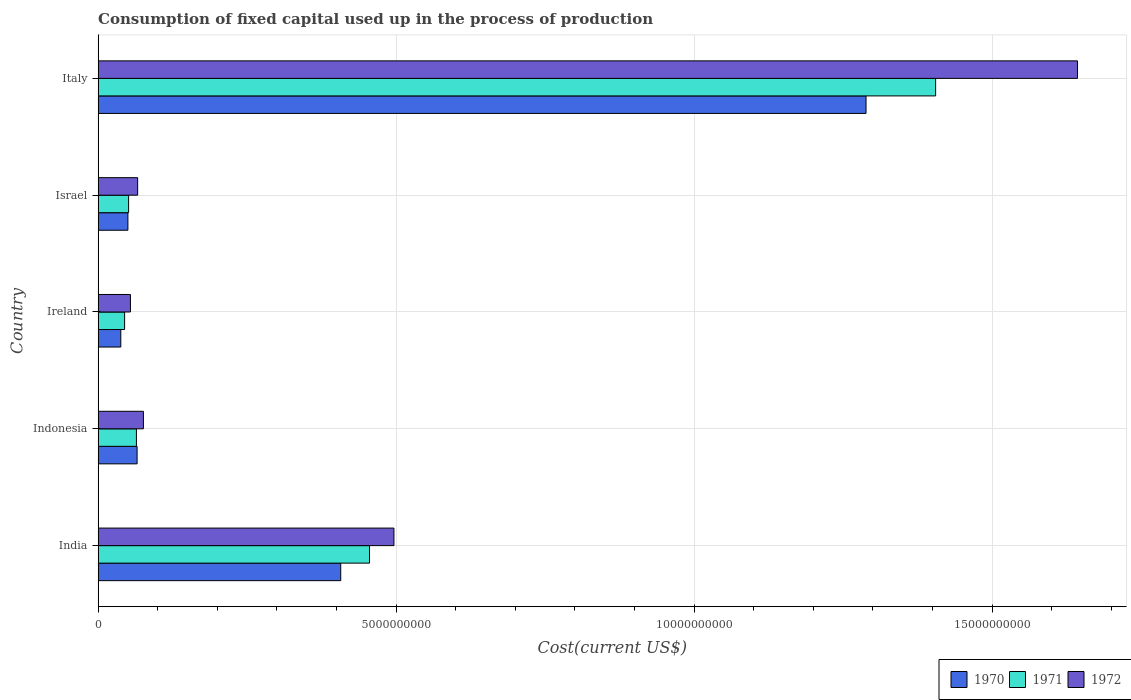How many different coloured bars are there?
Offer a very short reply. 3. How many groups of bars are there?
Provide a short and direct response. 5. Are the number of bars on each tick of the Y-axis equal?
Offer a very short reply. Yes. How many bars are there on the 5th tick from the top?
Offer a very short reply. 3. What is the amount consumed in the process of production in 1972 in Italy?
Your answer should be compact. 1.64e+1. Across all countries, what is the maximum amount consumed in the process of production in 1971?
Ensure brevity in your answer.  1.41e+1. Across all countries, what is the minimum amount consumed in the process of production in 1970?
Your response must be concise. 3.81e+08. In which country was the amount consumed in the process of production in 1970 maximum?
Make the answer very short. Italy. In which country was the amount consumed in the process of production in 1971 minimum?
Give a very brief answer. Ireland. What is the total amount consumed in the process of production in 1972 in the graph?
Give a very brief answer. 2.34e+1. What is the difference between the amount consumed in the process of production in 1972 in Israel and that in Italy?
Your response must be concise. -1.58e+1. What is the difference between the amount consumed in the process of production in 1970 in Ireland and the amount consumed in the process of production in 1972 in Indonesia?
Offer a terse response. -3.79e+08. What is the average amount consumed in the process of production in 1972 per country?
Offer a very short reply. 4.67e+09. What is the difference between the amount consumed in the process of production in 1970 and amount consumed in the process of production in 1971 in Italy?
Make the answer very short. -1.17e+09. What is the ratio of the amount consumed in the process of production in 1972 in Ireland to that in Italy?
Keep it short and to the point. 0.03. What is the difference between the highest and the second highest amount consumed in the process of production in 1972?
Your answer should be very brief. 1.15e+1. What is the difference between the highest and the lowest amount consumed in the process of production in 1971?
Provide a succinct answer. 1.36e+1. In how many countries, is the amount consumed in the process of production in 1970 greater than the average amount consumed in the process of production in 1970 taken over all countries?
Your answer should be compact. 2. What does the 1st bar from the top in Indonesia represents?
Provide a succinct answer. 1972. What does the 1st bar from the bottom in Indonesia represents?
Give a very brief answer. 1970. Is it the case that in every country, the sum of the amount consumed in the process of production in 1970 and amount consumed in the process of production in 1971 is greater than the amount consumed in the process of production in 1972?
Offer a terse response. Yes. How many countries are there in the graph?
Offer a terse response. 5. Where does the legend appear in the graph?
Make the answer very short. Bottom right. What is the title of the graph?
Your answer should be very brief. Consumption of fixed capital used up in the process of production. What is the label or title of the X-axis?
Offer a very short reply. Cost(current US$). What is the Cost(current US$) in 1970 in India?
Offer a very short reply. 4.07e+09. What is the Cost(current US$) of 1971 in India?
Offer a terse response. 4.55e+09. What is the Cost(current US$) of 1972 in India?
Provide a short and direct response. 4.96e+09. What is the Cost(current US$) of 1970 in Indonesia?
Ensure brevity in your answer.  6.54e+08. What is the Cost(current US$) in 1971 in Indonesia?
Provide a short and direct response. 6.43e+08. What is the Cost(current US$) of 1972 in Indonesia?
Your response must be concise. 7.60e+08. What is the Cost(current US$) of 1970 in Ireland?
Make the answer very short. 3.81e+08. What is the Cost(current US$) in 1971 in Ireland?
Give a very brief answer. 4.45e+08. What is the Cost(current US$) in 1972 in Ireland?
Offer a very short reply. 5.42e+08. What is the Cost(current US$) in 1970 in Israel?
Keep it short and to the point. 5.00e+08. What is the Cost(current US$) of 1971 in Israel?
Offer a very short reply. 5.12e+08. What is the Cost(current US$) of 1972 in Israel?
Ensure brevity in your answer.  6.63e+08. What is the Cost(current US$) of 1970 in Italy?
Offer a terse response. 1.29e+1. What is the Cost(current US$) of 1971 in Italy?
Your answer should be compact. 1.41e+1. What is the Cost(current US$) in 1972 in Italy?
Give a very brief answer. 1.64e+1. Across all countries, what is the maximum Cost(current US$) of 1970?
Your answer should be very brief. 1.29e+1. Across all countries, what is the maximum Cost(current US$) of 1971?
Your answer should be compact. 1.41e+1. Across all countries, what is the maximum Cost(current US$) in 1972?
Keep it short and to the point. 1.64e+1. Across all countries, what is the minimum Cost(current US$) in 1970?
Give a very brief answer. 3.81e+08. Across all countries, what is the minimum Cost(current US$) of 1971?
Offer a terse response. 4.45e+08. Across all countries, what is the minimum Cost(current US$) in 1972?
Offer a very short reply. 5.42e+08. What is the total Cost(current US$) in 1970 in the graph?
Offer a terse response. 1.85e+1. What is the total Cost(current US$) of 1971 in the graph?
Your answer should be compact. 2.02e+1. What is the total Cost(current US$) of 1972 in the graph?
Offer a terse response. 2.34e+1. What is the difference between the Cost(current US$) in 1970 in India and that in Indonesia?
Provide a succinct answer. 3.42e+09. What is the difference between the Cost(current US$) in 1971 in India and that in Indonesia?
Offer a terse response. 3.91e+09. What is the difference between the Cost(current US$) of 1972 in India and that in Indonesia?
Make the answer very short. 4.20e+09. What is the difference between the Cost(current US$) in 1970 in India and that in Ireland?
Provide a succinct answer. 3.69e+09. What is the difference between the Cost(current US$) in 1971 in India and that in Ireland?
Make the answer very short. 4.11e+09. What is the difference between the Cost(current US$) in 1972 in India and that in Ireland?
Ensure brevity in your answer.  4.42e+09. What is the difference between the Cost(current US$) of 1970 in India and that in Israel?
Your answer should be compact. 3.57e+09. What is the difference between the Cost(current US$) of 1971 in India and that in Israel?
Provide a short and direct response. 4.04e+09. What is the difference between the Cost(current US$) of 1972 in India and that in Israel?
Keep it short and to the point. 4.30e+09. What is the difference between the Cost(current US$) of 1970 in India and that in Italy?
Your answer should be very brief. -8.81e+09. What is the difference between the Cost(current US$) of 1971 in India and that in Italy?
Keep it short and to the point. -9.50e+09. What is the difference between the Cost(current US$) in 1972 in India and that in Italy?
Your response must be concise. -1.15e+1. What is the difference between the Cost(current US$) in 1970 in Indonesia and that in Ireland?
Make the answer very short. 2.73e+08. What is the difference between the Cost(current US$) in 1971 in Indonesia and that in Ireland?
Provide a short and direct response. 1.98e+08. What is the difference between the Cost(current US$) of 1972 in Indonesia and that in Ireland?
Your answer should be very brief. 2.18e+08. What is the difference between the Cost(current US$) of 1970 in Indonesia and that in Israel?
Give a very brief answer. 1.54e+08. What is the difference between the Cost(current US$) in 1971 in Indonesia and that in Israel?
Provide a short and direct response. 1.31e+08. What is the difference between the Cost(current US$) of 1972 in Indonesia and that in Israel?
Your answer should be compact. 9.66e+07. What is the difference between the Cost(current US$) in 1970 in Indonesia and that in Italy?
Provide a short and direct response. -1.22e+1. What is the difference between the Cost(current US$) in 1971 in Indonesia and that in Italy?
Make the answer very short. -1.34e+1. What is the difference between the Cost(current US$) in 1972 in Indonesia and that in Italy?
Provide a short and direct response. -1.57e+1. What is the difference between the Cost(current US$) in 1970 in Ireland and that in Israel?
Ensure brevity in your answer.  -1.19e+08. What is the difference between the Cost(current US$) in 1971 in Ireland and that in Israel?
Offer a very short reply. -6.70e+07. What is the difference between the Cost(current US$) in 1972 in Ireland and that in Israel?
Your response must be concise. -1.21e+08. What is the difference between the Cost(current US$) in 1970 in Ireland and that in Italy?
Make the answer very short. -1.25e+1. What is the difference between the Cost(current US$) of 1971 in Ireland and that in Italy?
Provide a short and direct response. -1.36e+1. What is the difference between the Cost(current US$) in 1972 in Ireland and that in Italy?
Keep it short and to the point. -1.59e+1. What is the difference between the Cost(current US$) in 1970 in Israel and that in Italy?
Keep it short and to the point. -1.24e+1. What is the difference between the Cost(current US$) of 1971 in Israel and that in Italy?
Give a very brief answer. -1.35e+1. What is the difference between the Cost(current US$) of 1972 in Israel and that in Italy?
Your answer should be very brief. -1.58e+1. What is the difference between the Cost(current US$) in 1970 in India and the Cost(current US$) in 1971 in Indonesia?
Give a very brief answer. 3.43e+09. What is the difference between the Cost(current US$) of 1970 in India and the Cost(current US$) of 1972 in Indonesia?
Your answer should be very brief. 3.31e+09. What is the difference between the Cost(current US$) of 1971 in India and the Cost(current US$) of 1972 in Indonesia?
Give a very brief answer. 3.79e+09. What is the difference between the Cost(current US$) of 1970 in India and the Cost(current US$) of 1971 in Ireland?
Provide a succinct answer. 3.63e+09. What is the difference between the Cost(current US$) in 1970 in India and the Cost(current US$) in 1972 in Ireland?
Offer a terse response. 3.53e+09. What is the difference between the Cost(current US$) of 1971 in India and the Cost(current US$) of 1972 in Ireland?
Give a very brief answer. 4.01e+09. What is the difference between the Cost(current US$) in 1970 in India and the Cost(current US$) in 1971 in Israel?
Keep it short and to the point. 3.56e+09. What is the difference between the Cost(current US$) of 1970 in India and the Cost(current US$) of 1972 in Israel?
Give a very brief answer. 3.41e+09. What is the difference between the Cost(current US$) in 1971 in India and the Cost(current US$) in 1972 in Israel?
Keep it short and to the point. 3.89e+09. What is the difference between the Cost(current US$) in 1970 in India and the Cost(current US$) in 1971 in Italy?
Your response must be concise. -9.98e+09. What is the difference between the Cost(current US$) in 1970 in India and the Cost(current US$) in 1972 in Italy?
Keep it short and to the point. -1.24e+1. What is the difference between the Cost(current US$) of 1971 in India and the Cost(current US$) of 1972 in Italy?
Provide a short and direct response. -1.19e+1. What is the difference between the Cost(current US$) of 1970 in Indonesia and the Cost(current US$) of 1971 in Ireland?
Offer a terse response. 2.09e+08. What is the difference between the Cost(current US$) of 1970 in Indonesia and the Cost(current US$) of 1972 in Ireland?
Provide a short and direct response. 1.12e+08. What is the difference between the Cost(current US$) in 1971 in Indonesia and the Cost(current US$) in 1972 in Ireland?
Provide a succinct answer. 1.01e+08. What is the difference between the Cost(current US$) in 1970 in Indonesia and the Cost(current US$) in 1971 in Israel?
Provide a short and direct response. 1.42e+08. What is the difference between the Cost(current US$) of 1970 in Indonesia and the Cost(current US$) of 1972 in Israel?
Ensure brevity in your answer.  -9.33e+06. What is the difference between the Cost(current US$) of 1971 in Indonesia and the Cost(current US$) of 1972 in Israel?
Offer a very short reply. -2.06e+07. What is the difference between the Cost(current US$) of 1970 in Indonesia and the Cost(current US$) of 1971 in Italy?
Your response must be concise. -1.34e+1. What is the difference between the Cost(current US$) of 1970 in Indonesia and the Cost(current US$) of 1972 in Italy?
Give a very brief answer. -1.58e+1. What is the difference between the Cost(current US$) in 1971 in Indonesia and the Cost(current US$) in 1972 in Italy?
Your answer should be compact. -1.58e+1. What is the difference between the Cost(current US$) of 1970 in Ireland and the Cost(current US$) of 1971 in Israel?
Your answer should be very brief. -1.31e+08. What is the difference between the Cost(current US$) of 1970 in Ireland and the Cost(current US$) of 1972 in Israel?
Your answer should be very brief. -2.83e+08. What is the difference between the Cost(current US$) in 1971 in Ireland and the Cost(current US$) in 1972 in Israel?
Give a very brief answer. -2.19e+08. What is the difference between the Cost(current US$) in 1970 in Ireland and the Cost(current US$) in 1971 in Italy?
Your answer should be compact. -1.37e+1. What is the difference between the Cost(current US$) of 1970 in Ireland and the Cost(current US$) of 1972 in Italy?
Ensure brevity in your answer.  -1.61e+1. What is the difference between the Cost(current US$) of 1971 in Ireland and the Cost(current US$) of 1972 in Italy?
Your answer should be compact. -1.60e+1. What is the difference between the Cost(current US$) in 1970 in Israel and the Cost(current US$) in 1971 in Italy?
Your answer should be very brief. -1.36e+1. What is the difference between the Cost(current US$) in 1970 in Israel and the Cost(current US$) in 1972 in Italy?
Your answer should be very brief. -1.59e+1. What is the difference between the Cost(current US$) of 1971 in Israel and the Cost(current US$) of 1972 in Italy?
Offer a terse response. -1.59e+1. What is the average Cost(current US$) of 1970 per country?
Your response must be concise. 3.70e+09. What is the average Cost(current US$) in 1971 per country?
Your response must be concise. 4.04e+09. What is the average Cost(current US$) in 1972 per country?
Make the answer very short. 4.67e+09. What is the difference between the Cost(current US$) in 1970 and Cost(current US$) in 1971 in India?
Your answer should be compact. -4.83e+08. What is the difference between the Cost(current US$) in 1970 and Cost(current US$) in 1972 in India?
Your answer should be compact. -8.93e+08. What is the difference between the Cost(current US$) in 1971 and Cost(current US$) in 1972 in India?
Your response must be concise. -4.09e+08. What is the difference between the Cost(current US$) of 1970 and Cost(current US$) of 1971 in Indonesia?
Provide a short and direct response. 1.13e+07. What is the difference between the Cost(current US$) of 1970 and Cost(current US$) of 1972 in Indonesia?
Your answer should be compact. -1.06e+08. What is the difference between the Cost(current US$) of 1971 and Cost(current US$) of 1972 in Indonesia?
Your answer should be very brief. -1.17e+08. What is the difference between the Cost(current US$) in 1970 and Cost(current US$) in 1971 in Ireland?
Ensure brevity in your answer.  -6.40e+07. What is the difference between the Cost(current US$) of 1970 and Cost(current US$) of 1972 in Ireland?
Offer a very short reply. -1.61e+08. What is the difference between the Cost(current US$) in 1971 and Cost(current US$) in 1972 in Ireland?
Give a very brief answer. -9.75e+07. What is the difference between the Cost(current US$) of 1970 and Cost(current US$) of 1971 in Israel?
Keep it short and to the point. -1.18e+07. What is the difference between the Cost(current US$) of 1970 and Cost(current US$) of 1972 in Israel?
Your answer should be compact. -1.63e+08. What is the difference between the Cost(current US$) of 1971 and Cost(current US$) of 1972 in Israel?
Your answer should be compact. -1.52e+08. What is the difference between the Cost(current US$) in 1970 and Cost(current US$) in 1971 in Italy?
Offer a very short reply. -1.17e+09. What is the difference between the Cost(current US$) in 1970 and Cost(current US$) in 1972 in Italy?
Offer a terse response. -3.55e+09. What is the difference between the Cost(current US$) in 1971 and Cost(current US$) in 1972 in Italy?
Provide a short and direct response. -2.38e+09. What is the ratio of the Cost(current US$) in 1970 in India to that in Indonesia?
Provide a succinct answer. 6.23. What is the ratio of the Cost(current US$) in 1971 in India to that in Indonesia?
Give a very brief answer. 7.09. What is the ratio of the Cost(current US$) in 1972 in India to that in Indonesia?
Give a very brief answer. 6.53. What is the ratio of the Cost(current US$) in 1970 in India to that in Ireland?
Your response must be concise. 10.69. What is the ratio of the Cost(current US$) of 1971 in India to that in Ireland?
Give a very brief answer. 10.24. What is the ratio of the Cost(current US$) of 1972 in India to that in Ireland?
Ensure brevity in your answer.  9.16. What is the ratio of the Cost(current US$) of 1970 in India to that in Israel?
Give a very brief answer. 8.14. What is the ratio of the Cost(current US$) of 1971 in India to that in Israel?
Give a very brief answer. 8.9. What is the ratio of the Cost(current US$) in 1972 in India to that in Israel?
Ensure brevity in your answer.  7.48. What is the ratio of the Cost(current US$) in 1970 in India to that in Italy?
Keep it short and to the point. 0.32. What is the ratio of the Cost(current US$) in 1971 in India to that in Italy?
Give a very brief answer. 0.32. What is the ratio of the Cost(current US$) in 1972 in India to that in Italy?
Ensure brevity in your answer.  0.3. What is the ratio of the Cost(current US$) in 1970 in Indonesia to that in Ireland?
Provide a short and direct response. 1.72. What is the ratio of the Cost(current US$) in 1971 in Indonesia to that in Ireland?
Provide a succinct answer. 1.45. What is the ratio of the Cost(current US$) in 1972 in Indonesia to that in Ireland?
Provide a succinct answer. 1.4. What is the ratio of the Cost(current US$) of 1970 in Indonesia to that in Israel?
Provide a succinct answer. 1.31. What is the ratio of the Cost(current US$) of 1971 in Indonesia to that in Israel?
Give a very brief answer. 1.26. What is the ratio of the Cost(current US$) in 1972 in Indonesia to that in Israel?
Your response must be concise. 1.15. What is the ratio of the Cost(current US$) in 1970 in Indonesia to that in Italy?
Your answer should be very brief. 0.05. What is the ratio of the Cost(current US$) of 1971 in Indonesia to that in Italy?
Ensure brevity in your answer.  0.05. What is the ratio of the Cost(current US$) of 1972 in Indonesia to that in Italy?
Your answer should be compact. 0.05. What is the ratio of the Cost(current US$) of 1970 in Ireland to that in Israel?
Provide a succinct answer. 0.76. What is the ratio of the Cost(current US$) in 1971 in Ireland to that in Israel?
Offer a very short reply. 0.87. What is the ratio of the Cost(current US$) in 1972 in Ireland to that in Israel?
Keep it short and to the point. 0.82. What is the ratio of the Cost(current US$) of 1970 in Ireland to that in Italy?
Ensure brevity in your answer.  0.03. What is the ratio of the Cost(current US$) of 1971 in Ireland to that in Italy?
Provide a succinct answer. 0.03. What is the ratio of the Cost(current US$) of 1972 in Ireland to that in Italy?
Your answer should be compact. 0.03. What is the ratio of the Cost(current US$) in 1970 in Israel to that in Italy?
Offer a very short reply. 0.04. What is the ratio of the Cost(current US$) in 1971 in Israel to that in Italy?
Ensure brevity in your answer.  0.04. What is the ratio of the Cost(current US$) in 1972 in Israel to that in Italy?
Make the answer very short. 0.04. What is the difference between the highest and the second highest Cost(current US$) in 1970?
Your answer should be compact. 8.81e+09. What is the difference between the highest and the second highest Cost(current US$) in 1971?
Ensure brevity in your answer.  9.50e+09. What is the difference between the highest and the second highest Cost(current US$) of 1972?
Provide a succinct answer. 1.15e+1. What is the difference between the highest and the lowest Cost(current US$) in 1970?
Your response must be concise. 1.25e+1. What is the difference between the highest and the lowest Cost(current US$) in 1971?
Ensure brevity in your answer.  1.36e+1. What is the difference between the highest and the lowest Cost(current US$) of 1972?
Offer a very short reply. 1.59e+1. 